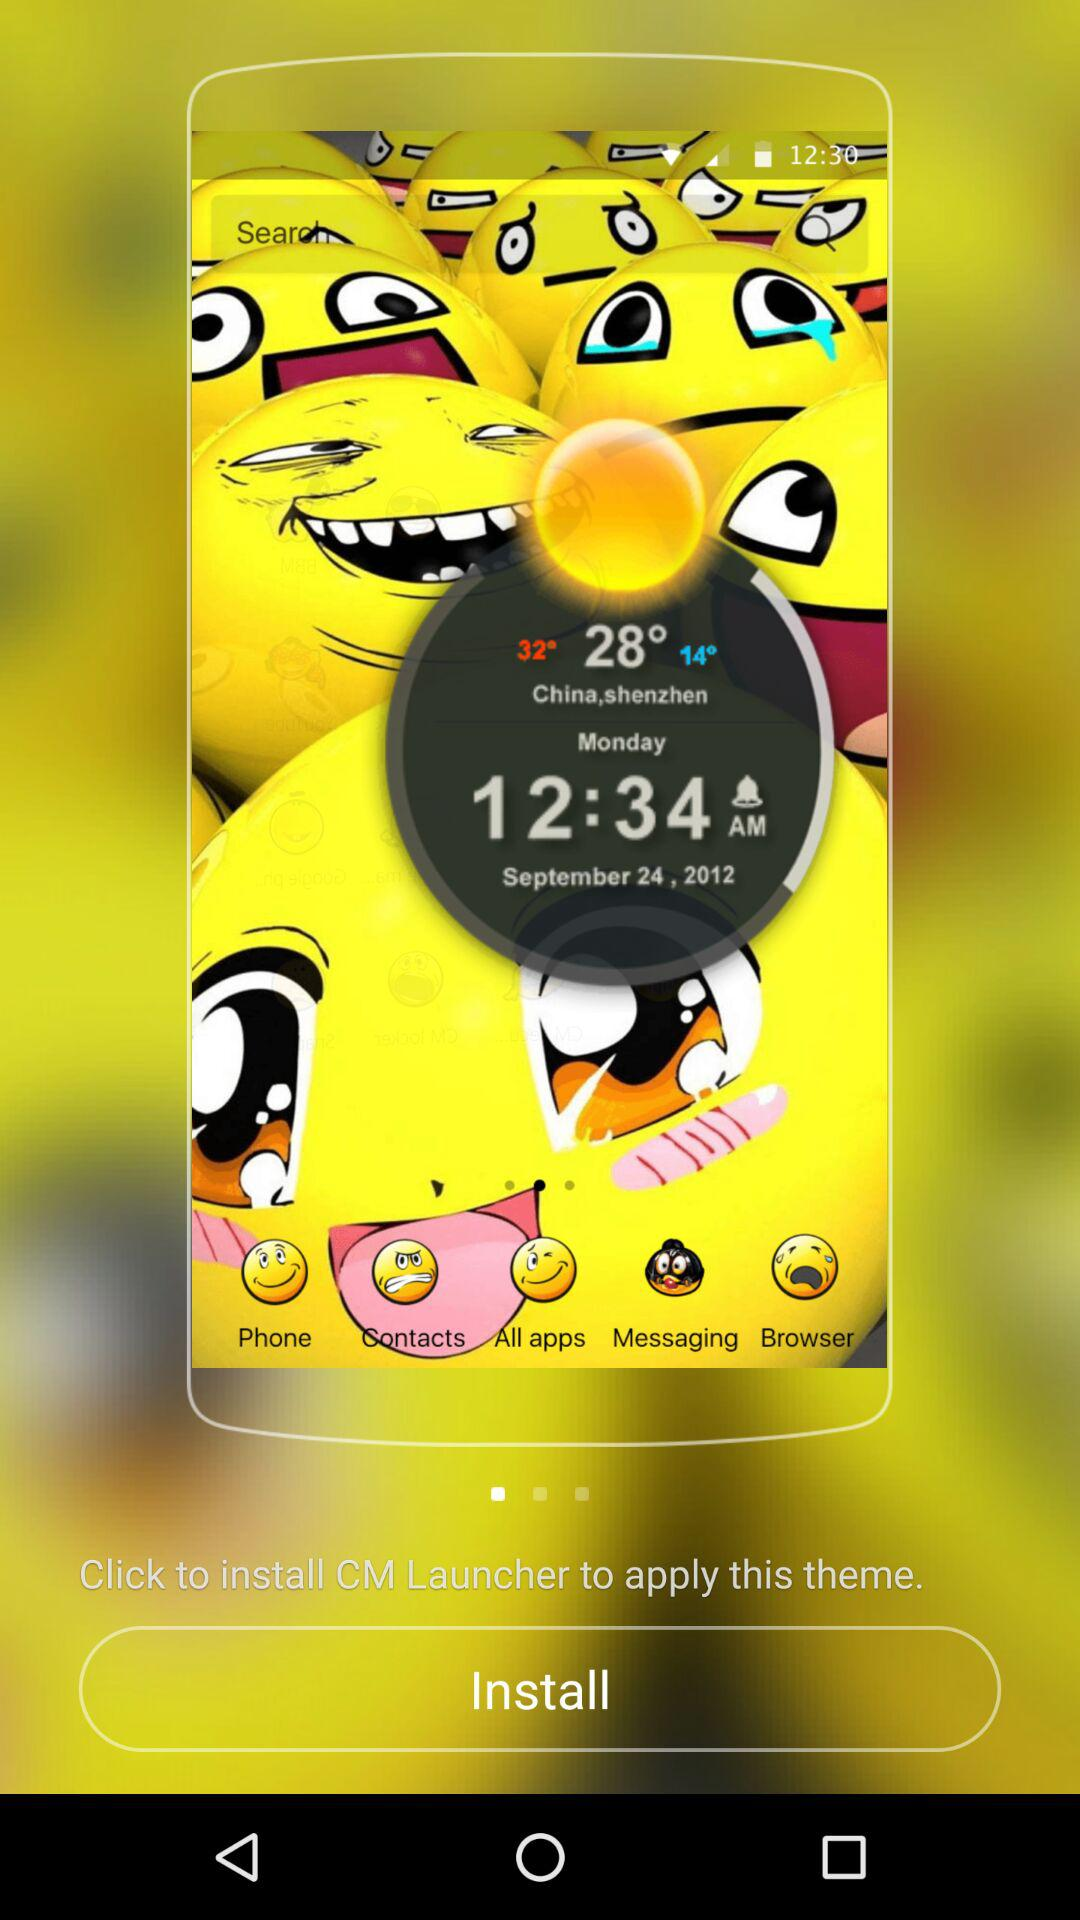What is the temperature in Shenzhen? The temperature in Shenzhen is 28°. 